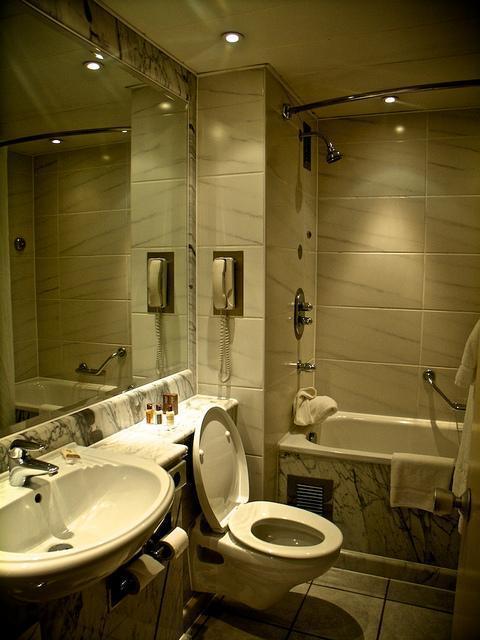How many sinks can you see?
Give a very brief answer. 1. How many people are wearing a tie in the picture?
Give a very brief answer. 0. 